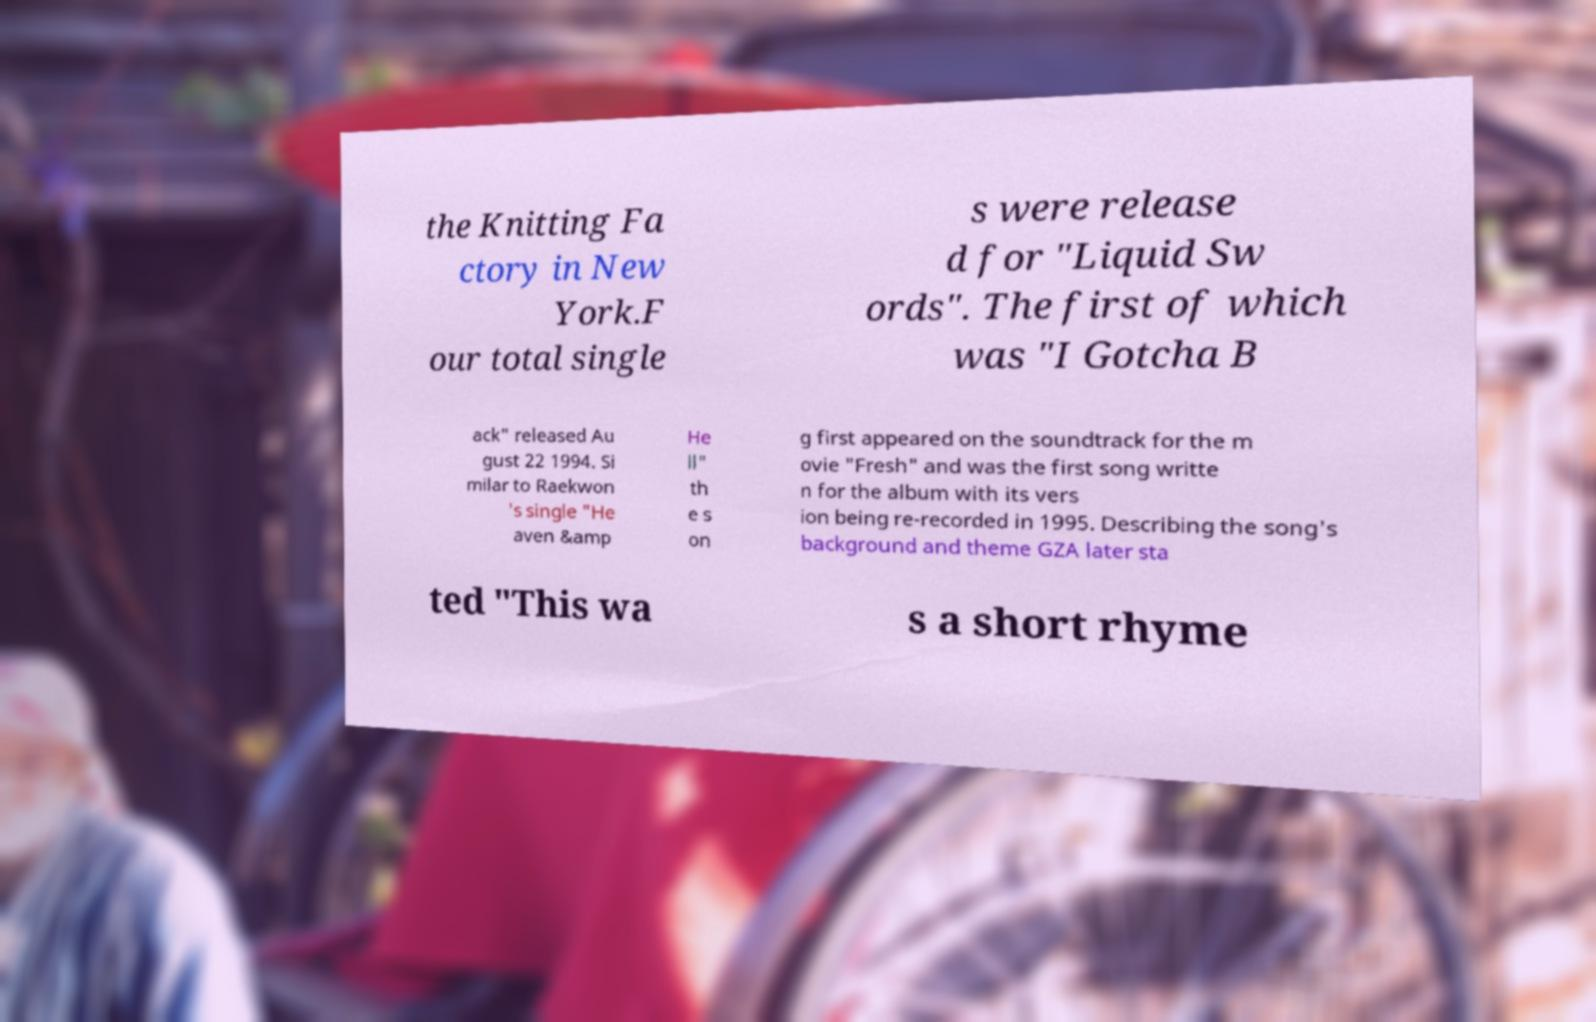Could you assist in decoding the text presented in this image and type it out clearly? the Knitting Fa ctory in New York.F our total single s were release d for "Liquid Sw ords". The first of which was "I Gotcha B ack" released Au gust 22 1994. Si milar to Raekwon 's single "He aven &amp He ll" th e s on g first appeared on the soundtrack for the m ovie "Fresh" and was the first song writte n for the album with its vers ion being re-recorded in 1995. Describing the song's background and theme GZA later sta ted "This wa s a short rhyme 